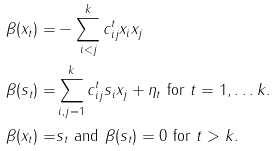<formula> <loc_0><loc_0><loc_500><loc_500>\beta ( x _ { t } ) = & - \sum _ { i < j } ^ { k } c _ { i j } ^ { t } x _ { i } x _ { j } \\ \beta ( s _ { t } ) = & \sum _ { i , j = 1 } ^ { k } c _ { i j } ^ { t } s _ { i } x _ { j } + \eta _ { t } \text { for } t = 1 , \dots k . \\ \beta ( x _ { t } ) = & s _ { t } \text { and } \beta ( s _ { t } ) = 0 \text { for } t > k .</formula> 